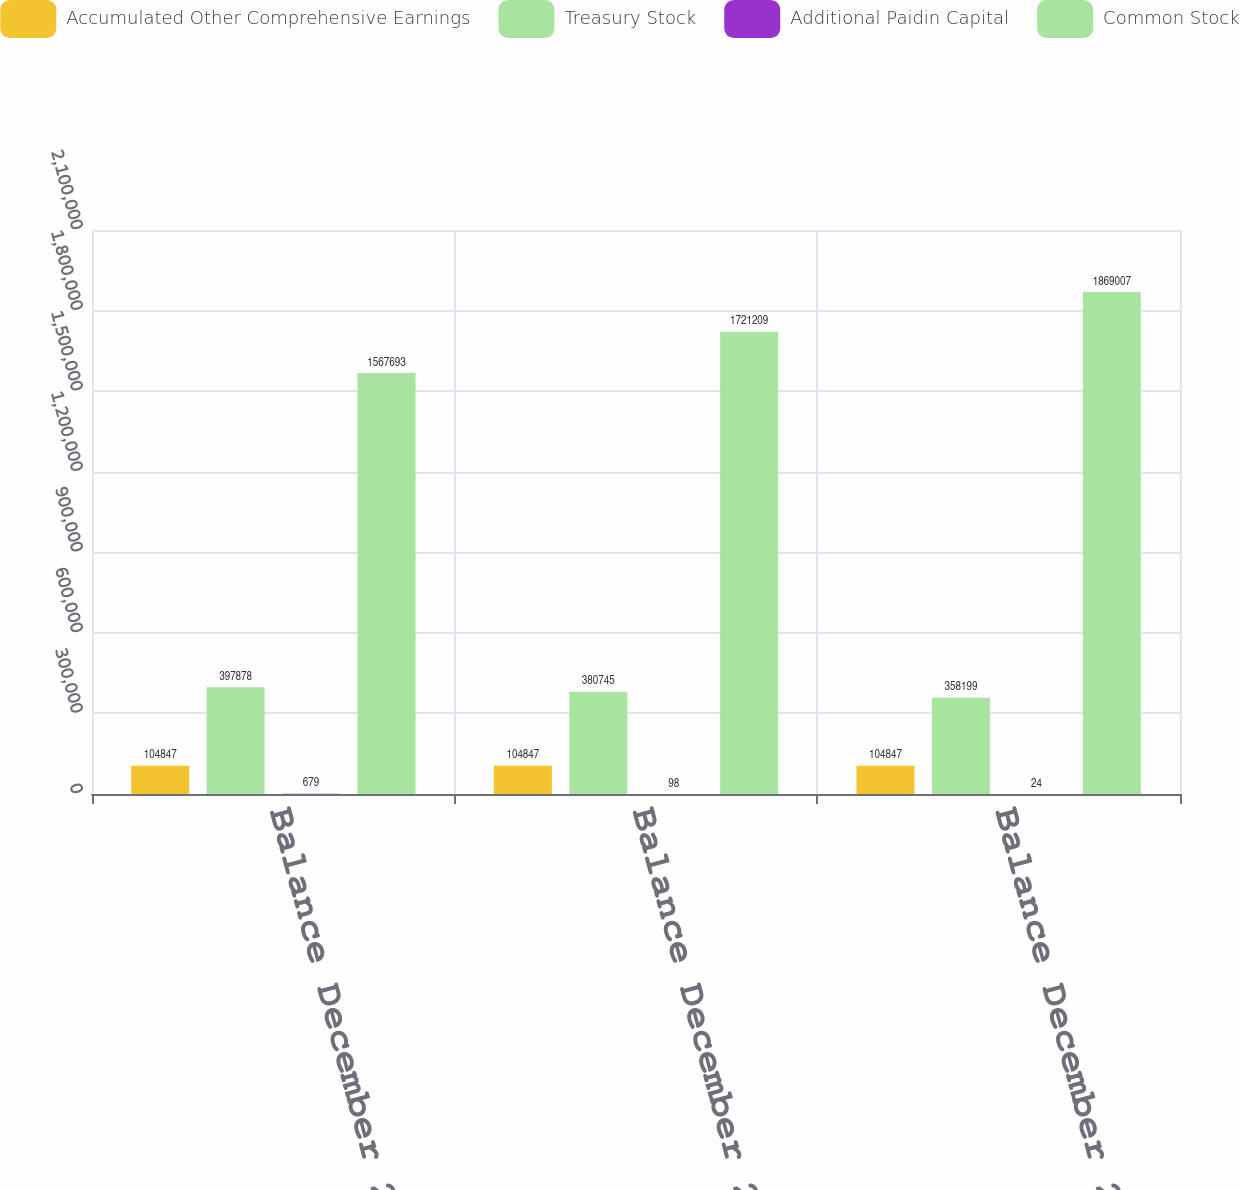Convert chart to OTSL. <chart><loc_0><loc_0><loc_500><loc_500><stacked_bar_chart><ecel><fcel>Balance December 28 2003<fcel>Balance December 26 2004<fcel>Balance December 25 2005<nl><fcel>Accumulated Other Comprehensive Earnings<fcel>104847<fcel>104847<fcel>104847<nl><fcel>Treasury Stock<fcel>397878<fcel>380745<fcel>358199<nl><fcel>Additional Paidin Capital<fcel>679<fcel>98<fcel>24<nl><fcel>Common Stock<fcel>1.56769e+06<fcel>1.72121e+06<fcel>1.86901e+06<nl></chart> 